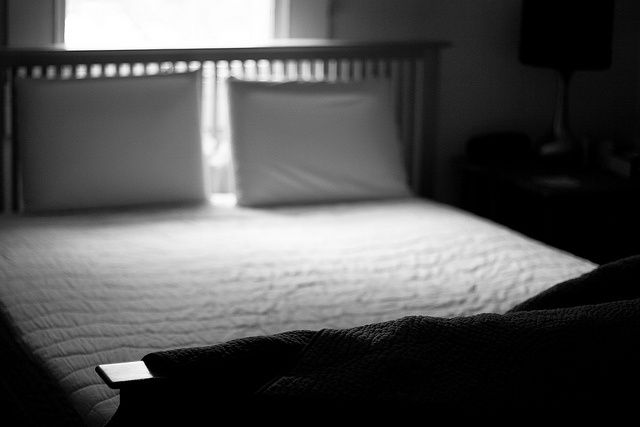Describe the objects in this image and their specific colors. I can see a bed in black, gray, gainsboro, and darkgray tones in this image. 